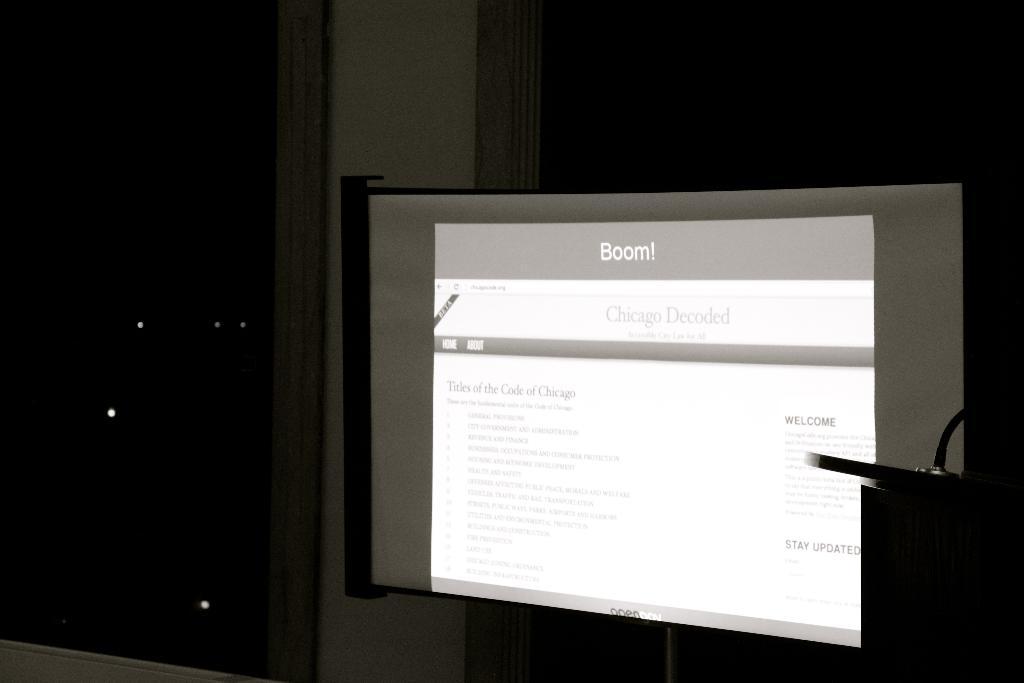What's written at the top of the slide, with an exclamation point?
Keep it short and to the point. Boom. What is written at the top of the screen?
Give a very brief answer. Boom!. 